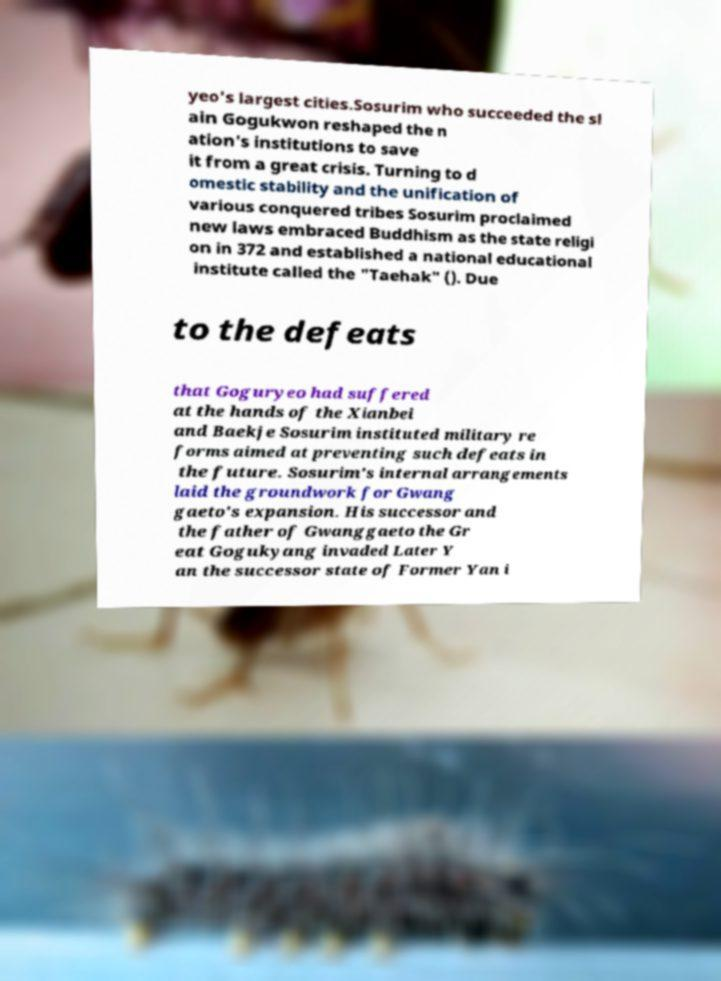Can you accurately transcribe the text from the provided image for me? yeo's largest cities.Sosurim who succeeded the sl ain Gogukwon reshaped the n ation's institutions to save it from a great crisis. Turning to d omestic stability and the unification of various conquered tribes Sosurim proclaimed new laws embraced Buddhism as the state religi on in 372 and established a national educational institute called the "Taehak" (). Due to the defeats that Goguryeo had suffered at the hands of the Xianbei and Baekje Sosurim instituted military re forms aimed at preventing such defeats in the future. Sosurim's internal arrangements laid the groundwork for Gwang gaeto's expansion. His successor and the father of Gwanggaeto the Gr eat Gogukyang invaded Later Y an the successor state of Former Yan i 